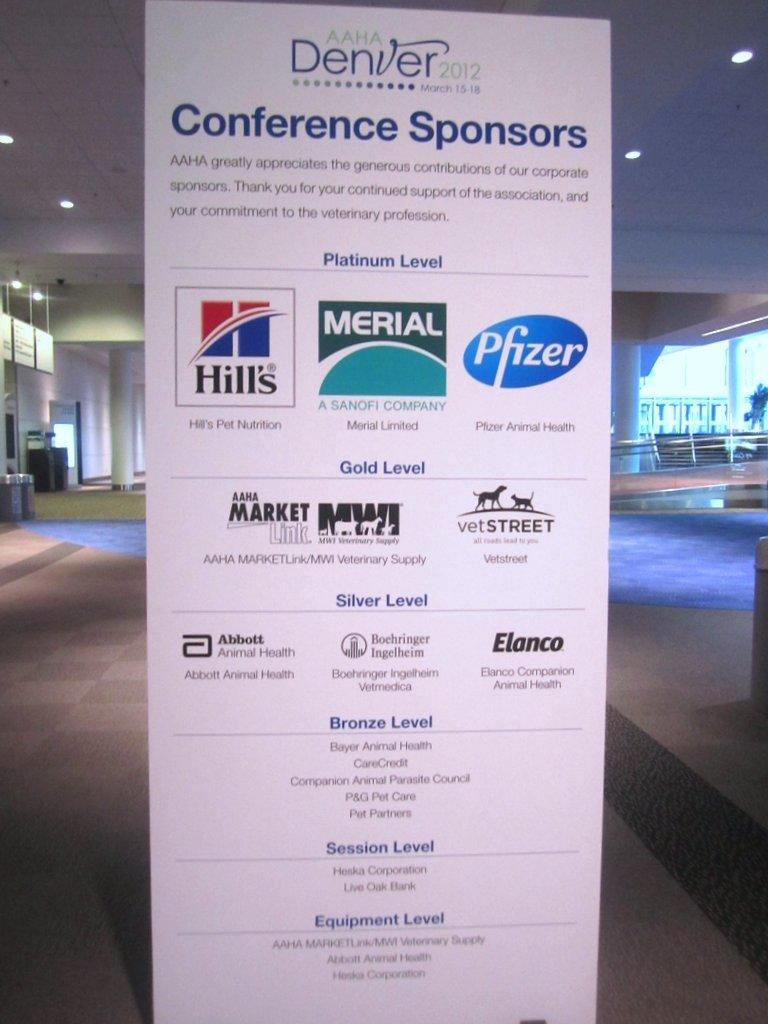<image>
Render a clear and concise summary of the photo. A sign with a list of conference sponsors sits in a lobby area. 